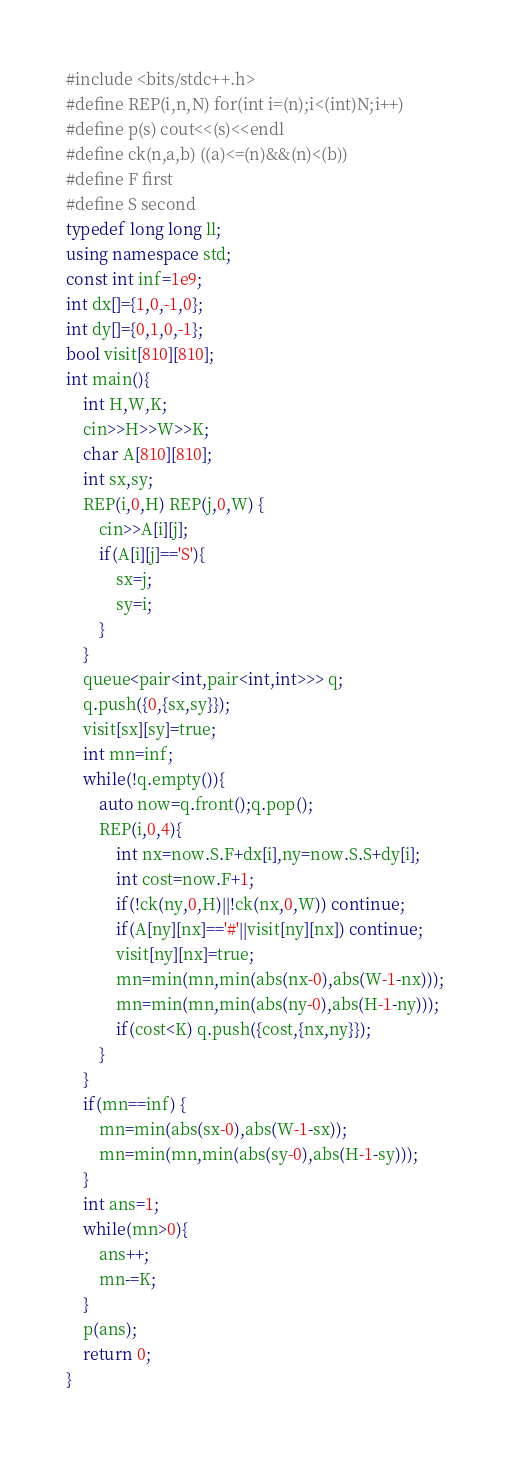Convert code to text. <code><loc_0><loc_0><loc_500><loc_500><_C++_>#include <bits/stdc++.h>
#define REP(i,n,N) for(int i=(n);i<(int)N;i++)
#define p(s) cout<<(s)<<endl
#define ck(n,a,b) ((a)<=(n)&&(n)<(b))
#define F first
#define S second
typedef long long ll;
using namespace std;
const int inf=1e9;
int dx[]={1,0,-1,0};
int dy[]={0,1,0,-1};
bool visit[810][810];
int main(){
	int H,W,K;
	cin>>H>>W>>K;
	char A[810][810];
	int sx,sy;
	REP(i,0,H) REP(j,0,W) {
		cin>>A[i][j];
		if(A[i][j]=='S'){
			sx=j;
			sy=i;
		}
	}
	queue<pair<int,pair<int,int>>> q;
	q.push({0,{sx,sy}});
	visit[sx][sy]=true;
	int mn=inf;
	while(!q.empty()){
		auto now=q.front();q.pop();
		REP(i,0,4){
			int nx=now.S.F+dx[i],ny=now.S.S+dy[i];
			int cost=now.F+1;
			if(!ck(ny,0,H)||!ck(nx,0,W)) continue;
			if(A[ny][nx]=='#'||visit[ny][nx]) continue;
			visit[ny][nx]=true;
			mn=min(mn,min(abs(nx-0),abs(W-1-nx)));
			mn=min(mn,min(abs(ny-0),abs(H-1-ny)));
			if(cost<K) q.push({cost,{nx,ny}});
		}
	}
	if(mn==inf) {
		mn=min(abs(sx-0),abs(W-1-sx));
		mn=min(mn,min(abs(sy-0),abs(H-1-sy)));
	}
	int ans=1;
	while(mn>0){
		ans++;
		mn-=K;
	}
	p(ans);
	return 0;
}
</code> 